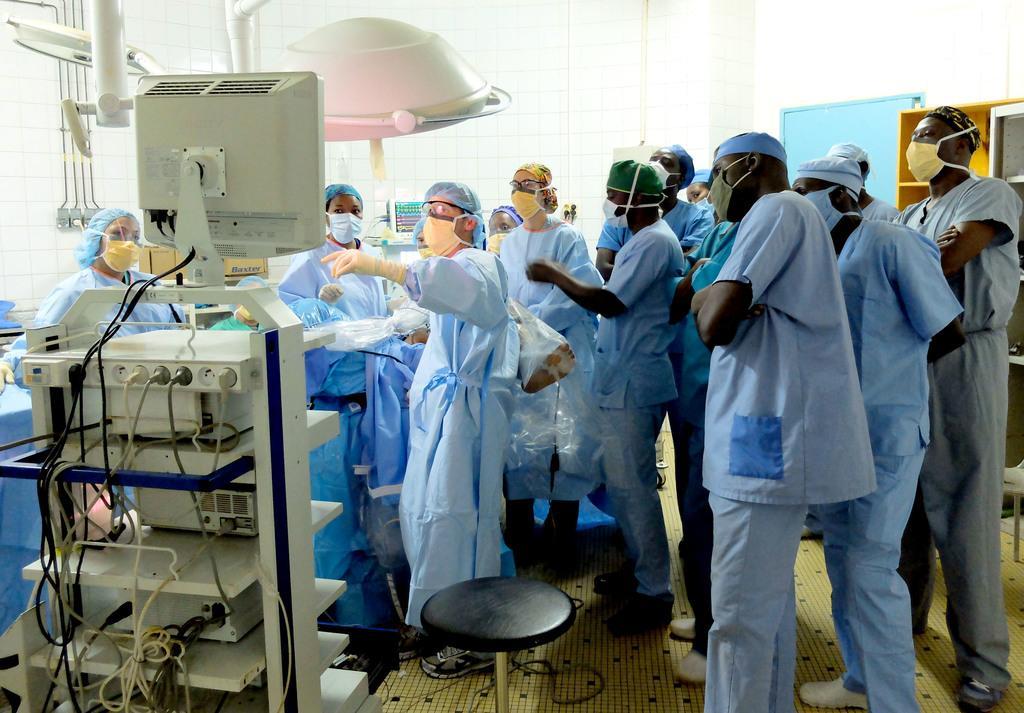Can you describe this image briefly? In this image I can see number of persons wearing blue colored dresses and masks are standing. I can see a huge electric equipment which is cream in color and few wires which are black and cream in color. I can see a stool and the cream colored floor. In the background I can see a pipe, the wall, the door and the rack. 